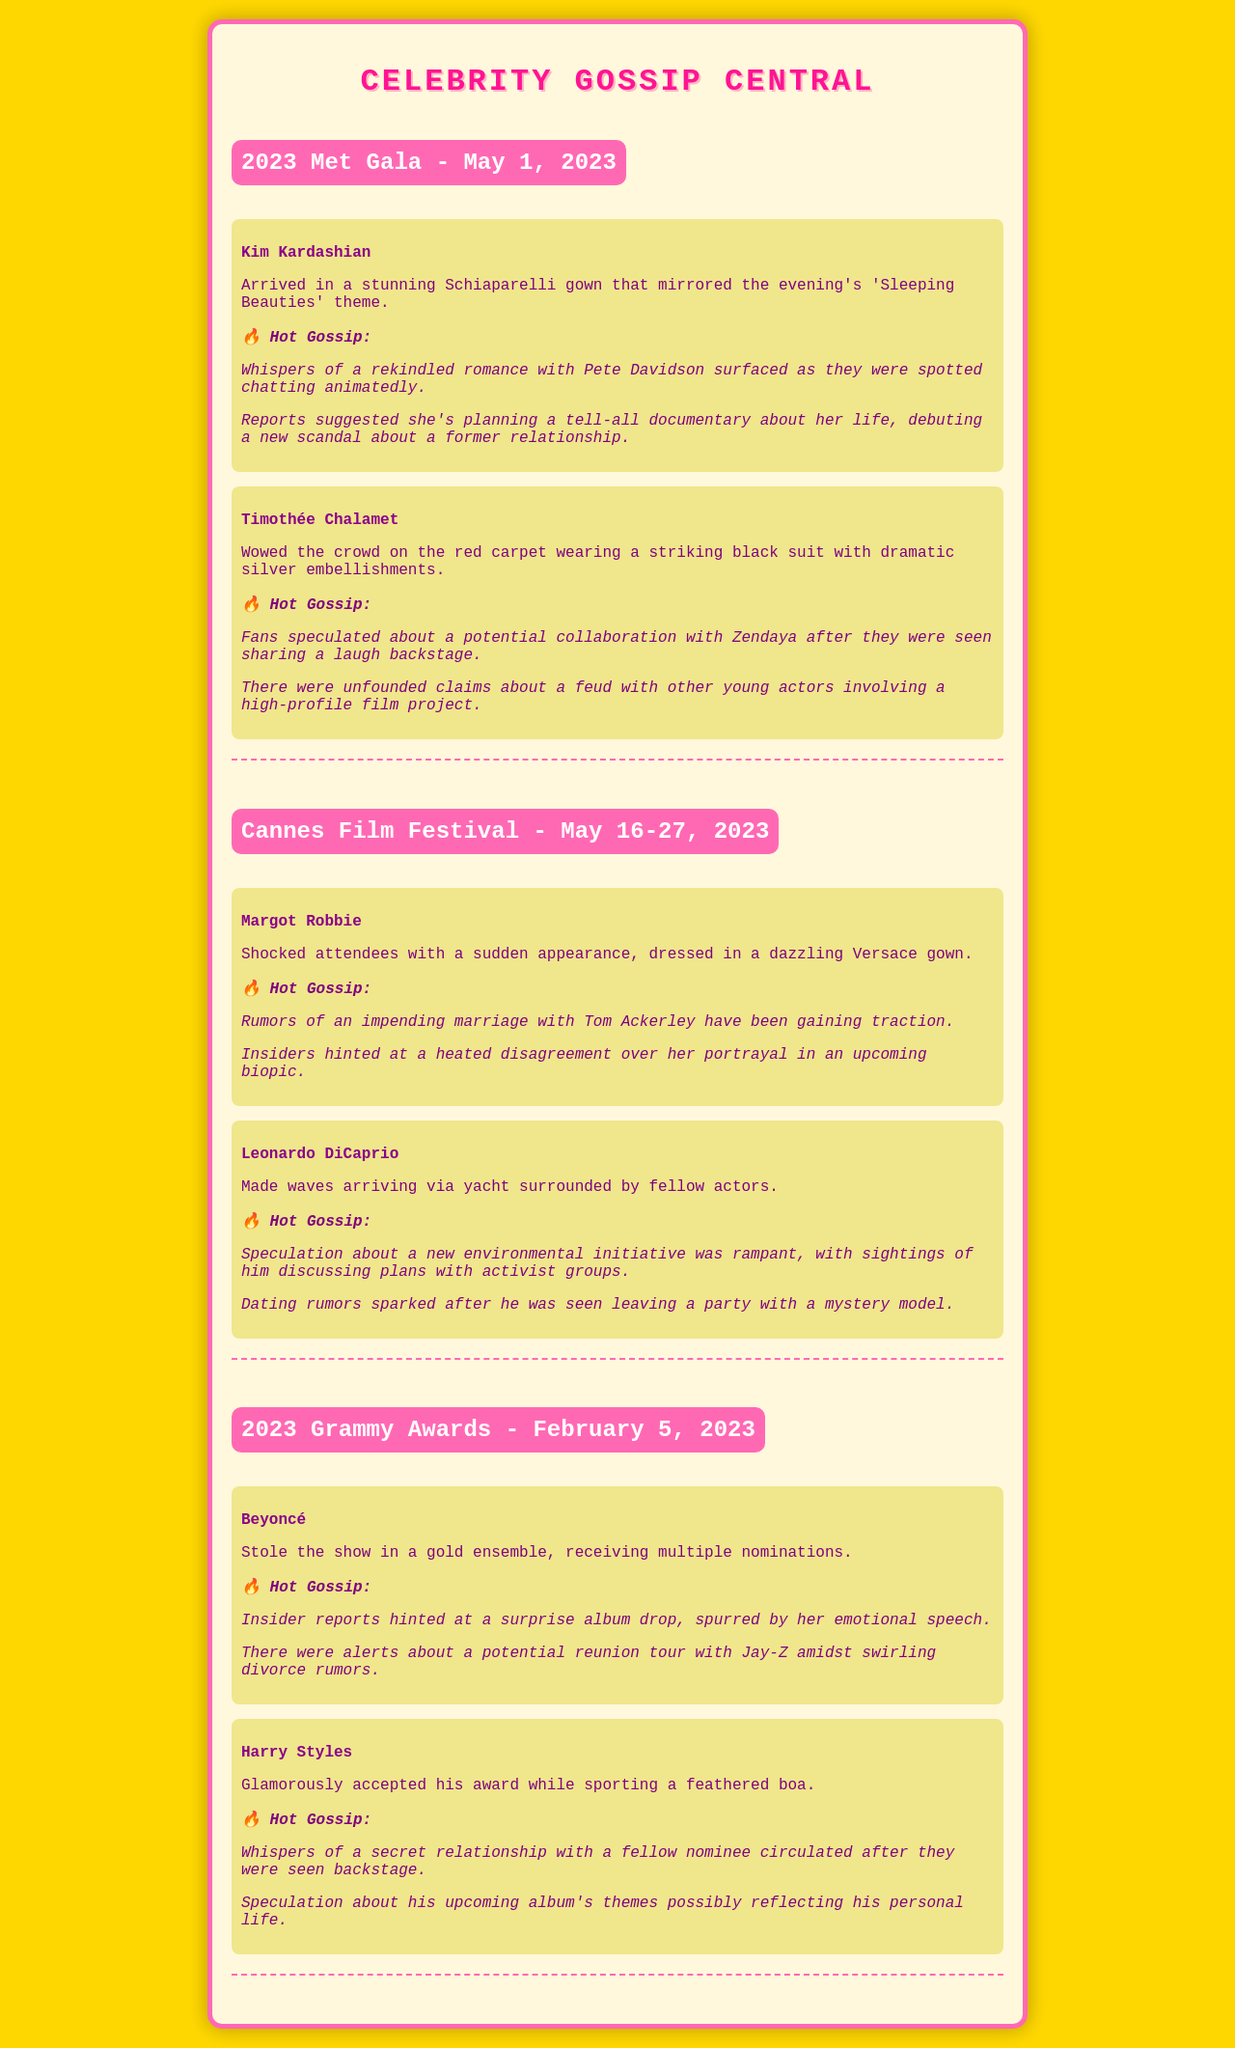What is the date of the 2023 Met Gala? The document states that the 2023 Met Gala occurred on May 1, 2023.
Answer: May 1, 2023 Who wore a Schiaparelli gown at the Met Gala? Kim Kardashian is mentioned as wearing a stunning Schiaparelli gown during the Met Gala.
Answer: Kim Kardashian What is the theme of the 2023 Met Gala? The theme for the evening was 'Sleeping Beauties,' as noted in the document.
Answer: Sleeping Beauties Which celebrity shocked attendees at the Cannes Film Festival? Margot Robbie is highlighted in the document as having a sudden appearance that shocked attendees.
Answer: Margot Robbie What rumors were associated with Beyoncé at the Grammy Awards? Insider reports hinted at a surprise album drop and a potential reunion tour with Jay-Z amidst divorce rumors.
Answer: Surprise album drop; reunion tour Who was seen with a mystery model after a party? Leonardo DiCaprio was the celebrity mentioned as being seen leaving a party with a mystery model.
Answer: Leonardo DiCaprio What did Harry Styles wear at the Grammy Awards? The document mentions Harry Styles sporting a feathered boa while accepting his award.
Answer: Feathered boa Which event featured Timothée Chalamet? Timothée Chalamet was a part of the 2023 Met Gala, according to the document.
Answer: 2023 Met Gala 